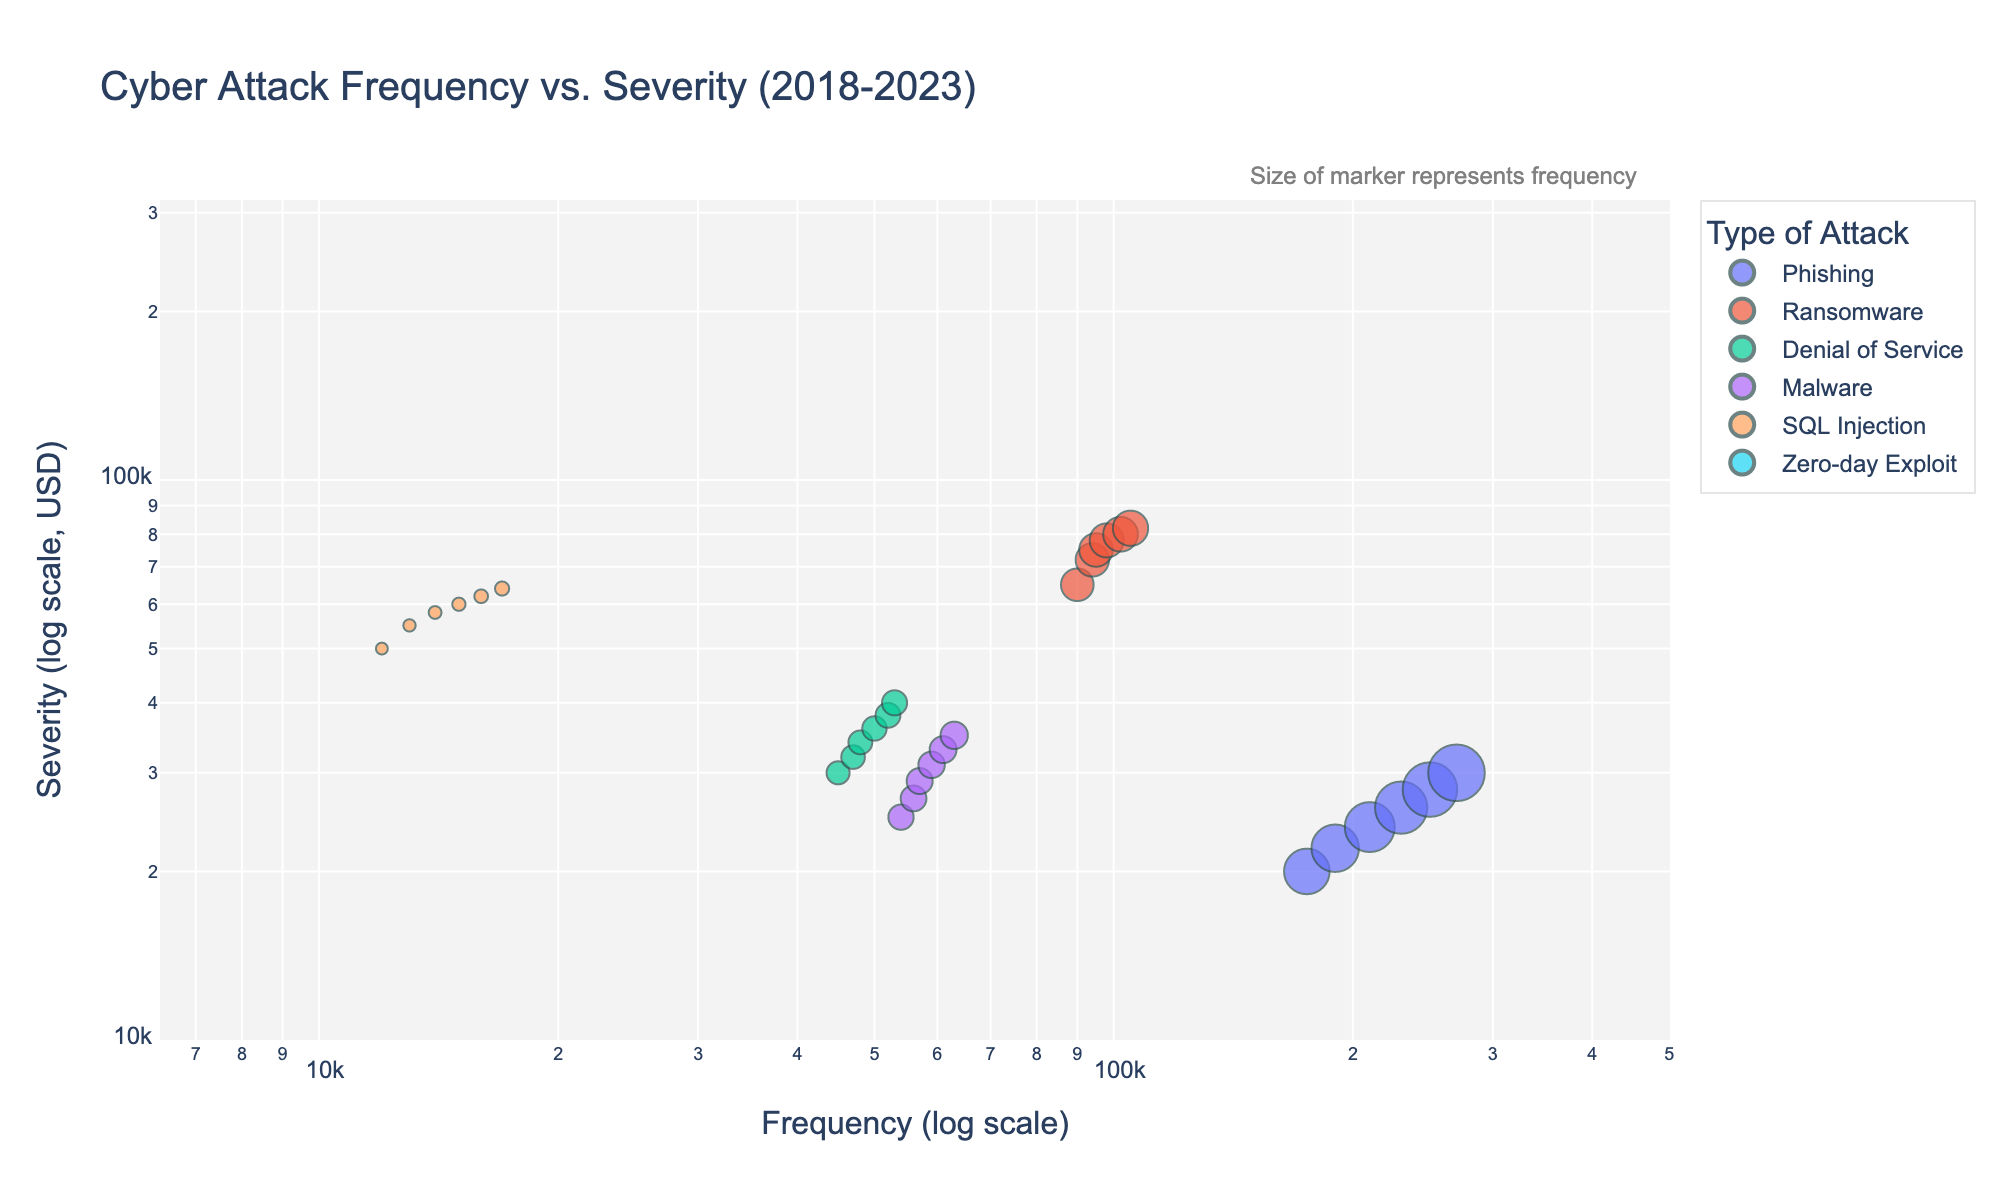what is the title of the figure? The title of the figure is clearly shown at the top of the plot. It reads "Cyber Attack Frequency vs. Severity (2018-2023)".
Answer: Cyber Attack Frequency vs. Severity (2018-2023) What is depicted on the x-axis and y-axis of the figure? The x-axis represents "Frequency (log scale)" and the y-axis represents "Severity (log scale, USD)". This is indicated by the axis labels.
Answer: Frequency and Severity (USD) Which type of attack has the highest severity in 2023? To answer this, locate the points corresponding to the year 2023 and compare their y-axis values. The type with the highest severity will be at the top. "Zero-day Exploit" has the highest y-value in 2023.
Answer: Zero-day Exploit Between 2018 and 2023, which type of attack shows a consistent increase in frequency every year? Observe the scatter points for each type of attack over the years and see which one consistently moves right on the log scale x-axis. "Phishing" shows a consistent increase in frequency.
Answer: Phishing Which type of attack had the smallest frequency in 2019 compared to other types? Locate the points for 2019 and identify the point with the smallest x-axis value. "Zero-day Exploit" had the smallest frequency in 2019.
Answer: Zero-day Exploit How does the severity of Ransomware in 2020 compare to that in 2019? Identify Ransomware points for both 2020 and 2019, then compare their y-axis values. The 2020 point is higher, indicating an increase.
Answer: Increased Considering the log scales, what can be inferred about the relationship between frequency and severity? On a log-log plot, if points form a linear trend, there’s a power-law relation. Points spread unevenly suggest no simple relation, indicating complex dynamics between frequency and severity.
Answer: No simple relation Which type of attack has the highest variability in frequency from 2018 to 2023? Check the spread of points along the x-axis for each type. "Phishing" shows the widest range indicating high variability in frequency over time.
Answer: Phishing What can be inferred about the financial impact of a Zero-day Exploit compared to other attacks? Zero-day Exploit points are consistently higher on the y-axis, indicating a higher average financial impact.
Answer: Higher financial impact 